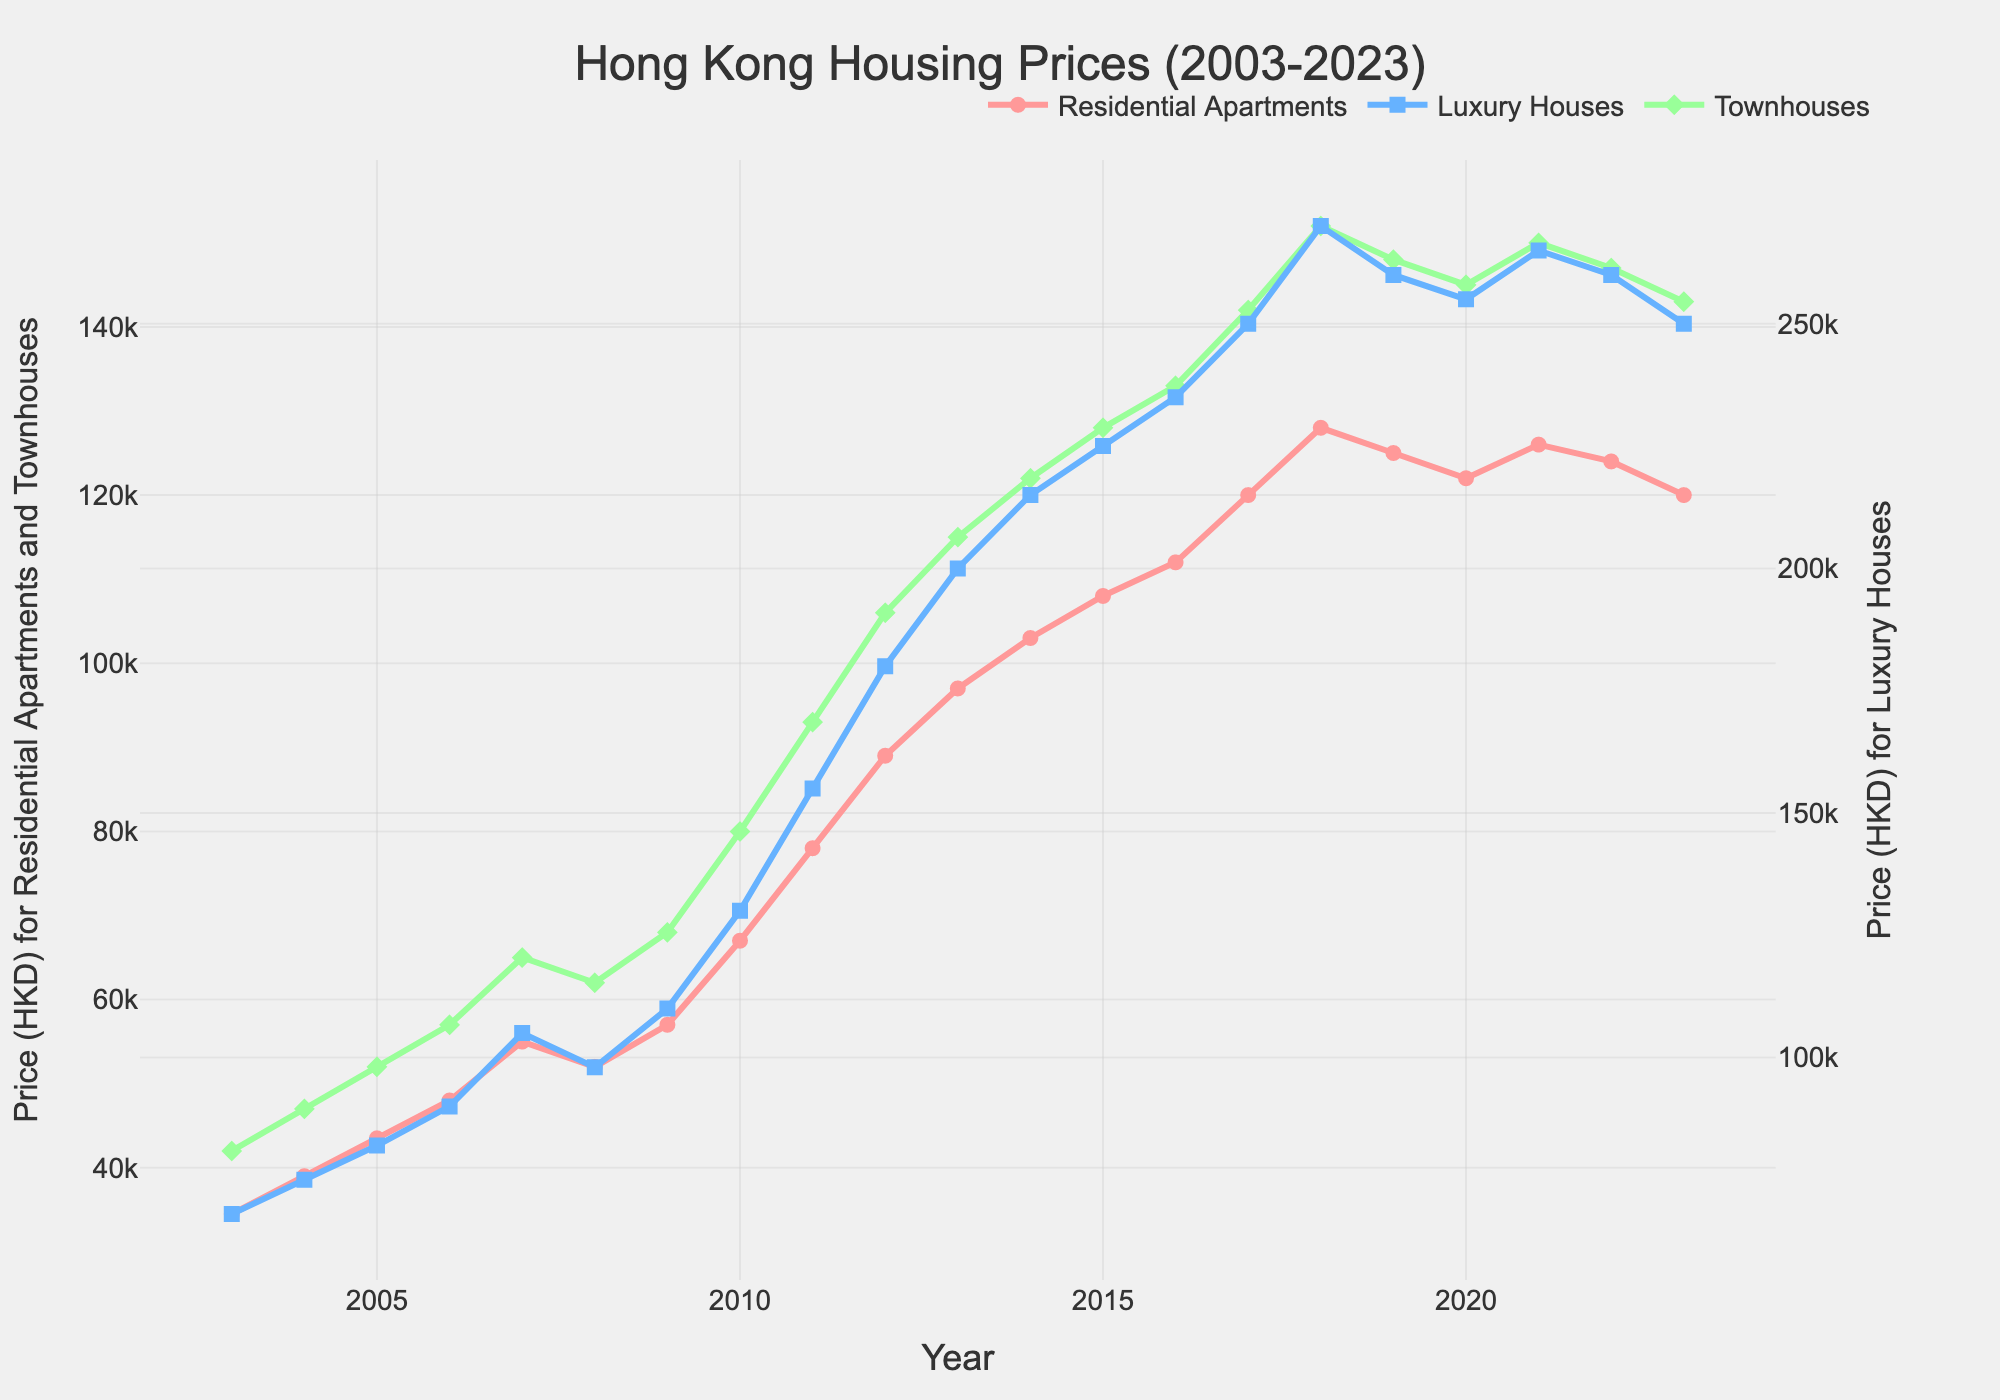What's the average price of residential apartments in the first five years (2003-2007)? The prices of residential apartments in the first five years are 34500, 39000, 43500, 48000, and 55000. Adding these values together gives 220000. Dividing by 5 (the number of years) gives 220000 / 5 = 44000.
Answer: 44000 Which property type experienced the highest price increase between 2003 and 2023? For Residential Apartments, the prices increased from 34500 to 120000, a difference of 120000 - 34500 = 85500. For Luxury Houses, the prices increased from 68000 to 250000, a difference of 250000 - 68000 = 182000. For Townhouses, the prices increased from 42000 to 143000, a difference of 143000 - 42000 = 101000. Luxury Houses had the highest increase.
Answer: Luxury Houses In which year did Luxury Houses surpass 200000 for the first time? The trendline for Luxury Houses crosses 200000 in the year 2013.
Answer: 2013 What's the price difference between Townhouses and Residential Apartments in 2019? In 2019, the price of Residential Apartments was 125000 and the price of Townhouses was 148000. The difference is 148000 - 125000 = 23000.
Answer: 23000 Which property type had the most stable prices from 2020 to 2023? By observing the slopes of the lines from 2020 to 2023, Residential Apartments and Townhouses have slight downward trends compared to Luxury Houses, which also has a slight reduction but the smallest magnitude.
Answer: Luxury Houses What’s the overall trend for Residential Apartments from 2003 to 2023? The prices of Residential Apartments tended to increase steadily from 2003 to 2018, peaked in 2018 at 128000, and then showed a slight decline but remaining high compared to the early years.
Answer: Increasing In which year did Townhouses see their biggest single-year price jump? The largest year-over-year increase in prices for Townhouses was from 2009 (68000) to 2010 (80000), where it jumped by 12000.
Answer: 2010 What's the price difference between Luxury Houses and Residential Apartments in 2010? In 2010, the price of Luxury Houses was 130000 and the price of Residential Apartments was 67000. The difference is 130000 - 67000 = 63000.
Answer: 63000 Which years did all three property types see a price decline? The years where all three property types saw a price decline is evident in the years 2019 to 2023.
Answer: 2023 